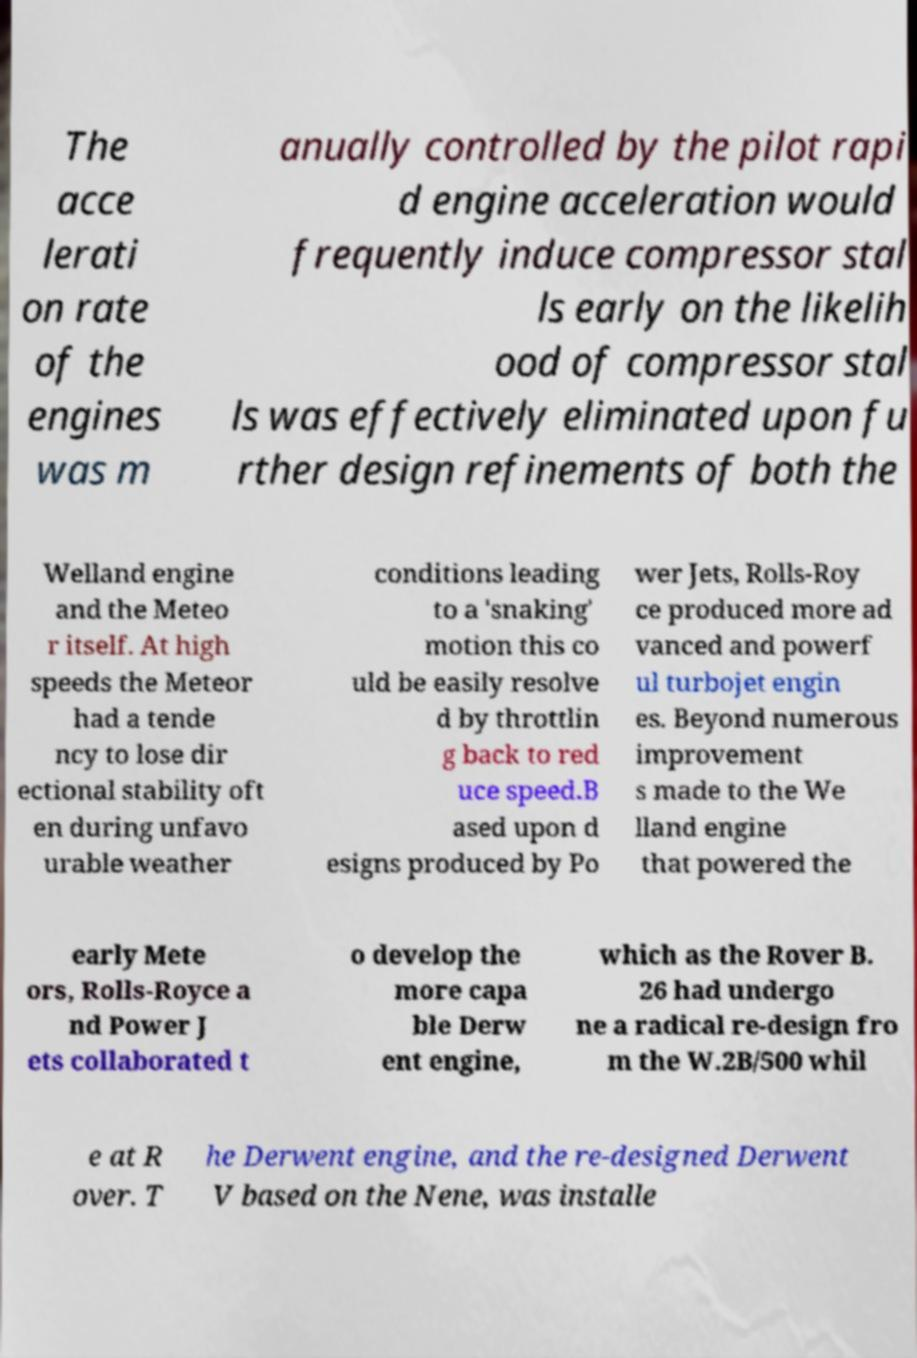Can you accurately transcribe the text from the provided image for me? The acce lerati on rate of the engines was m anually controlled by the pilot rapi d engine acceleration would frequently induce compressor stal ls early on the likelih ood of compressor stal ls was effectively eliminated upon fu rther design refinements of both the Welland engine and the Meteo r itself. At high speeds the Meteor had a tende ncy to lose dir ectional stability oft en during unfavo urable weather conditions leading to a 'snaking' motion this co uld be easily resolve d by throttlin g back to red uce speed.B ased upon d esigns produced by Po wer Jets, Rolls-Roy ce produced more ad vanced and powerf ul turbojet engin es. Beyond numerous improvement s made to the We lland engine that powered the early Mete ors, Rolls-Royce a nd Power J ets collaborated t o develop the more capa ble Derw ent engine, which as the Rover B. 26 had undergo ne a radical re-design fro m the W.2B/500 whil e at R over. T he Derwent engine, and the re-designed Derwent V based on the Nene, was installe 